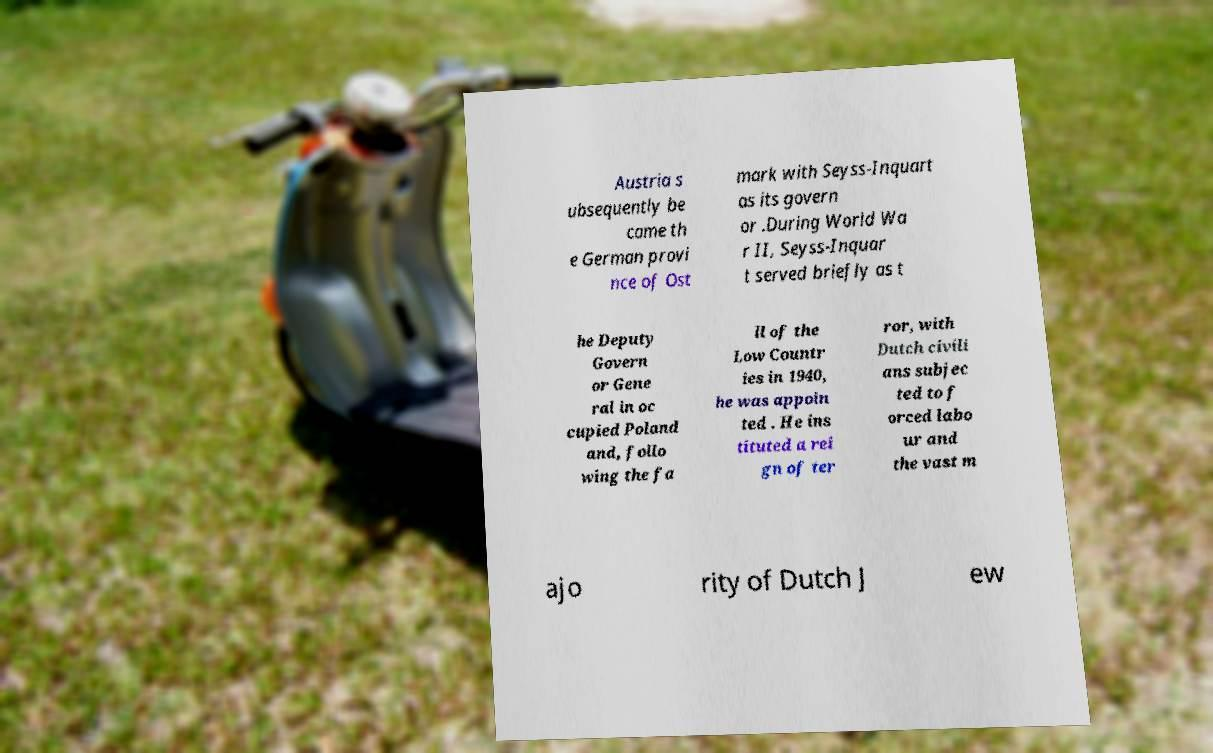Could you assist in decoding the text presented in this image and type it out clearly? Austria s ubsequently be came th e German provi nce of Ost mark with Seyss-Inquart as its govern or .During World Wa r II, Seyss-Inquar t served briefly as t he Deputy Govern or Gene ral in oc cupied Poland and, follo wing the fa ll of the Low Countr ies in 1940, he was appoin ted . He ins tituted a rei gn of ter ror, with Dutch civili ans subjec ted to f orced labo ur and the vast m ajo rity of Dutch J ew 